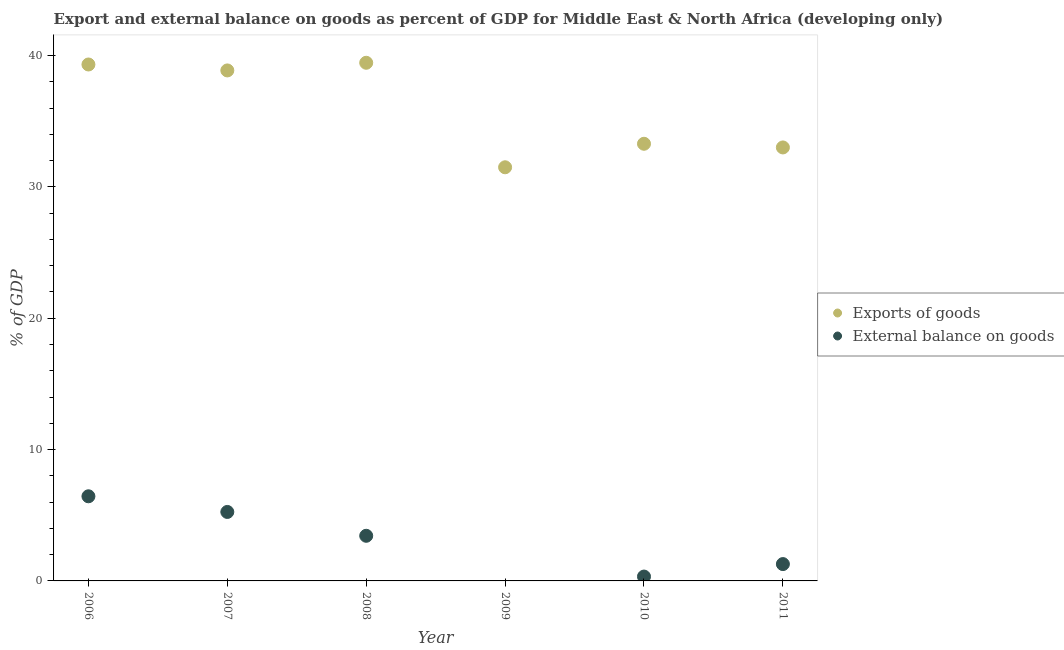How many different coloured dotlines are there?
Provide a succinct answer. 2. What is the external balance on goods as percentage of gdp in 2011?
Offer a very short reply. 1.28. Across all years, what is the maximum external balance on goods as percentage of gdp?
Provide a short and direct response. 6.44. Across all years, what is the minimum export of goods as percentage of gdp?
Offer a terse response. 31.49. In which year was the export of goods as percentage of gdp maximum?
Offer a terse response. 2008. What is the total export of goods as percentage of gdp in the graph?
Offer a terse response. 215.39. What is the difference between the export of goods as percentage of gdp in 2006 and that in 2011?
Provide a short and direct response. 6.31. What is the difference between the export of goods as percentage of gdp in 2006 and the external balance on goods as percentage of gdp in 2009?
Make the answer very short. 39.31. What is the average external balance on goods as percentage of gdp per year?
Your response must be concise. 2.79. In the year 2008, what is the difference between the external balance on goods as percentage of gdp and export of goods as percentage of gdp?
Offer a terse response. -36.01. In how many years, is the external balance on goods as percentage of gdp greater than 14 %?
Offer a terse response. 0. What is the ratio of the export of goods as percentage of gdp in 2006 to that in 2008?
Ensure brevity in your answer.  1. Is the export of goods as percentage of gdp in 2006 less than that in 2007?
Provide a succinct answer. No. What is the difference between the highest and the second highest export of goods as percentage of gdp?
Provide a short and direct response. 0.13. What is the difference between the highest and the lowest export of goods as percentage of gdp?
Your answer should be compact. 7.96. In how many years, is the export of goods as percentage of gdp greater than the average export of goods as percentage of gdp taken over all years?
Keep it short and to the point. 3. Does the external balance on goods as percentage of gdp monotonically increase over the years?
Ensure brevity in your answer.  No. Is the external balance on goods as percentage of gdp strictly greater than the export of goods as percentage of gdp over the years?
Ensure brevity in your answer.  No. How many dotlines are there?
Offer a terse response. 2. How many years are there in the graph?
Provide a succinct answer. 6. What is the difference between two consecutive major ticks on the Y-axis?
Provide a short and direct response. 10. Are the values on the major ticks of Y-axis written in scientific E-notation?
Offer a terse response. No. Does the graph contain any zero values?
Provide a succinct answer. Yes. Does the graph contain grids?
Your response must be concise. No. How many legend labels are there?
Give a very brief answer. 2. What is the title of the graph?
Provide a short and direct response. Export and external balance on goods as percent of GDP for Middle East & North Africa (developing only). What is the label or title of the X-axis?
Offer a terse response. Year. What is the label or title of the Y-axis?
Offer a terse response. % of GDP. What is the % of GDP of Exports of goods in 2006?
Make the answer very short. 39.31. What is the % of GDP in External balance on goods in 2006?
Keep it short and to the point. 6.44. What is the % of GDP of Exports of goods in 2007?
Your response must be concise. 38.86. What is the % of GDP in External balance on goods in 2007?
Give a very brief answer. 5.25. What is the % of GDP of Exports of goods in 2008?
Provide a succinct answer. 39.44. What is the % of GDP of External balance on goods in 2008?
Make the answer very short. 3.44. What is the % of GDP in Exports of goods in 2009?
Ensure brevity in your answer.  31.49. What is the % of GDP of Exports of goods in 2010?
Ensure brevity in your answer.  33.28. What is the % of GDP of External balance on goods in 2010?
Make the answer very short. 0.33. What is the % of GDP in Exports of goods in 2011?
Provide a succinct answer. 33. What is the % of GDP of External balance on goods in 2011?
Keep it short and to the point. 1.28. Across all years, what is the maximum % of GDP in Exports of goods?
Ensure brevity in your answer.  39.44. Across all years, what is the maximum % of GDP in External balance on goods?
Your response must be concise. 6.44. Across all years, what is the minimum % of GDP in Exports of goods?
Give a very brief answer. 31.49. Across all years, what is the minimum % of GDP of External balance on goods?
Offer a very short reply. 0. What is the total % of GDP in Exports of goods in the graph?
Give a very brief answer. 215.39. What is the total % of GDP of External balance on goods in the graph?
Your response must be concise. 16.74. What is the difference between the % of GDP of Exports of goods in 2006 and that in 2007?
Make the answer very short. 0.45. What is the difference between the % of GDP of External balance on goods in 2006 and that in 2007?
Provide a succinct answer. 1.19. What is the difference between the % of GDP of Exports of goods in 2006 and that in 2008?
Ensure brevity in your answer.  -0.13. What is the difference between the % of GDP of External balance on goods in 2006 and that in 2008?
Provide a short and direct response. 3.01. What is the difference between the % of GDP in Exports of goods in 2006 and that in 2009?
Provide a short and direct response. 7.83. What is the difference between the % of GDP of Exports of goods in 2006 and that in 2010?
Provide a short and direct response. 6.04. What is the difference between the % of GDP in External balance on goods in 2006 and that in 2010?
Offer a very short reply. 6.11. What is the difference between the % of GDP of Exports of goods in 2006 and that in 2011?
Your answer should be compact. 6.31. What is the difference between the % of GDP of External balance on goods in 2006 and that in 2011?
Your answer should be very brief. 5.16. What is the difference between the % of GDP of Exports of goods in 2007 and that in 2008?
Your answer should be very brief. -0.58. What is the difference between the % of GDP in External balance on goods in 2007 and that in 2008?
Offer a very short reply. 1.81. What is the difference between the % of GDP in Exports of goods in 2007 and that in 2009?
Offer a terse response. 7.37. What is the difference between the % of GDP in Exports of goods in 2007 and that in 2010?
Offer a very short reply. 5.58. What is the difference between the % of GDP of External balance on goods in 2007 and that in 2010?
Offer a very short reply. 4.92. What is the difference between the % of GDP in Exports of goods in 2007 and that in 2011?
Offer a terse response. 5.86. What is the difference between the % of GDP in External balance on goods in 2007 and that in 2011?
Give a very brief answer. 3.97. What is the difference between the % of GDP in Exports of goods in 2008 and that in 2009?
Give a very brief answer. 7.96. What is the difference between the % of GDP in Exports of goods in 2008 and that in 2010?
Ensure brevity in your answer.  6.17. What is the difference between the % of GDP of External balance on goods in 2008 and that in 2010?
Keep it short and to the point. 3.1. What is the difference between the % of GDP of Exports of goods in 2008 and that in 2011?
Your response must be concise. 6.45. What is the difference between the % of GDP in External balance on goods in 2008 and that in 2011?
Ensure brevity in your answer.  2.15. What is the difference between the % of GDP in Exports of goods in 2009 and that in 2010?
Keep it short and to the point. -1.79. What is the difference between the % of GDP of Exports of goods in 2009 and that in 2011?
Offer a terse response. -1.51. What is the difference between the % of GDP of Exports of goods in 2010 and that in 2011?
Your response must be concise. 0.28. What is the difference between the % of GDP in External balance on goods in 2010 and that in 2011?
Give a very brief answer. -0.95. What is the difference between the % of GDP of Exports of goods in 2006 and the % of GDP of External balance on goods in 2007?
Provide a short and direct response. 34.06. What is the difference between the % of GDP of Exports of goods in 2006 and the % of GDP of External balance on goods in 2008?
Make the answer very short. 35.88. What is the difference between the % of GDP of Exports of goods in 2006 and the % of GDP of External balance on goods in 2010?
Your answer should be very brief. 38.98. What is the difference between the % of GDP in Exports of goods in 2006 and the % of GDP in External balance on goods in 2011?
Provide a short and direct response. 38.03. What is the difference between the % of GDP in Exports of goods in 2007 and the % of GDP in External balance on goods in 2008?
Your response must be concise. 35.43. What is the difference between the % of GDP in Exports of goods in 2007 and the % of GDP in External balance on goods in 2010?
Provide a short and direct response. 38.53. What is the difference between the % of GDP in Exports of goods in 2007 and the % of GDP in External balance on goods in 2011?
Make the answer very short. 37.58. What is the difference between the % of GDP in Exports of goods in 2008 and the % of GDP in External balance on goods in 2010?
Your answer should be compact. 39.11. What is the difference between the % of GDP of Exports of goods in 2008 and the % of GDP of External balance on goods in 2011?
Keep it short and to the point. 38.16. What is the difference between the % of GDP of Exports of goods in 2009 and the % of GDP of External balance on goods in 2010?
Provide a short and direct response. 31.16. What is the difference between the % of GDP in Exports of goods in 2009 and the % of GDP in External balance on goods in 2011?
Offer a very short reply. 30.21. What is the difference between the % of GDP in Exports of goods in 2010 and the % of GDP in External balance on goods in 2011?
Offer a very short reply. 32. What is the average % of GDP in Exports of goods per year?
Ensure brevity in your answer.  35.9. What is the average % of GDP of External balance on goods per year?
Ensure brevity in your answer.  2.79. In the year 2006, what is the difference between the % of GDP of Exports of goods and % of GDP of External balance on goods?
Give a very brief answer. 32.87. In the year 2007, what is the difference between the % of GDP in Exports of goods and % of GDP in External balance on goods?
Provide a short and direct response. 33.61. In the year 2008, what is the difference between the % of GDP of Exports of goods and % of GDP of External balance on goods?
Your response must be concise. 36.01. In the year 2010, what is the difference between the % of GDP of Exports of goods and % of GDP of External balance on goods?
Offer a very short reply. 32.95. In the year 2011, what is the difference between the % of GDP in Exports of goods and % of GDP in External balance on goods?
Offer a very short reply. 31.72. What is the ratio of the % of GDP in Exports of goods in 2006 to that in 2007?
Offer a very short reply. 1.01. What is the ratio of the % of GDP in External balance on goods in 2006 to that in 2007?
Your answer should be very brief. 1.23. What is the ratio of the % of GDP in External balance on goods in 2006 to that in 2008?
Your response must be concise. 1.88. What is the ratio of the % of GDP in Exports of goods in 2006 to that in 2009?
Your response must be concise. 1.25. What is the ratio of the % of GDP of Exports of goods in 2006 to that in 2010?
Ensure brevity in your answer.  1.18. What is the ratio of the % of GDP of External balance on goods in 2006 to that in 2010?
Offer a very short reply. 19.42. What is the ratio of the % of GDP of Exports of goods in 2006 to that in 2011?
Make the answer very short. 1.19. What is the ratio of the % of GDP in External balance on goods in 2006 to that in 2011?
Give a very brief answer. 5.03. What is the ratio of the % of GDP in Exports of goods in 2007 to that in 2008?
Make the answer very short. 0.99. What is the ratio of the % of GDP of External balance on goods in 2007 to that in 2008?
Make the answer very short. 1.53. What is the ratio of the % of GDP of Exports of goods in 2007 to that in 2009?
Offer a very short reply. 1.23. What is the ratio of the % of GDP in Exports of goods in 2007 to that in 2010?
Your answer should be compact. 1.17. What is the ratio of the % of GDP in External balance on goods in 2007 to that in 2010?
Your response must be concise. 15.82. What is the ratio of the % of GDP of Exports of goods in 2007 to that in 2011?
Offer a very short reply. 1.18. What is the ratio of the % of GDP of External balance on goods in 2007 to that in 2011?
Your answer should be compact. 4.1. What is the ratio of the % of GDP in Exports of goods in 2008 to that in 2009?
Offer a very short reply. 1.25. What is the ratio of the % of GDP in Exports of goods in 2008 to that in 2010?
Give a very brief answer. 1.19. What is the ratio of the % of GDP of External balance on goods in 2008 to that in 2010?
Your answer should be very brief. 10.35. What is the ratio of the % of GDP in Exports of goods in 2008 to that in 2011?
Ensure brevity in your answer.  1.2. What is the ratio of the % of GDP in External balance on goods in 2008 to that in 2011?
Provide a succinct answer. 2.68. What is the ratio of the % of GDP in Exports of goods in 2009 to that in 2010?
Keep it short and to the point. 0.95. What is the ratio of the % of GDP in Exports of goods in 2009 to that in 2011?
Your answer should be very brief. 0.95. What is the ratio of the % of GDP of Exports of goods in 2010 to that in 2011?
Ensure brevity in your answer.  1.01. What is the ratio of the % of GDP in External balance on goods in 2010 to that in 2011?
Ensure brevity in your answer.  0.26. What is the difference between the highest and the second highest % of GDP in Exports of goods?
Make the answer very short. 0.13. What is the difference between the highest and the second highest % of GDP in External balance on goods?
Offer a very short reply. 1.19. What is the difference between the highest and the lowest % of GDP in Exports of goods?
Offer a very short reply. 7.96. What is the difference between the highest and the lowest % of GDP of External balance on goods?
Give a very brief answer. 6.44. 